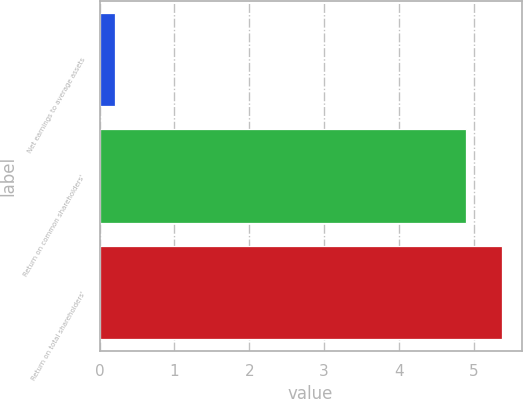Convert chart. <chart><loc_0><loc_0><loc_500><loc_500><bar_chart><fcel>Net earnings to average assets<fcel>Return on common shareholders'<fcel>Return on total shareholders'<nl><fcel>0.2<fcel>4.9<fcel>5.37<nl></chart> 